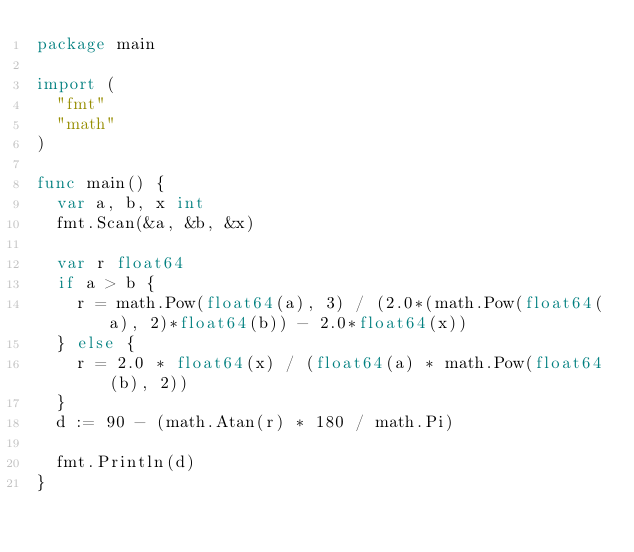<code> <loc_0><loc_0><loc_500><loc_500><_Go_>package main

import (
	"fmt"
	"math"
)

func main() {
	var a, b, x int
	fmt.Scan(&a, &b, &x)

	var r float64
	if a > b {
		r = math.Pow(float64(a), 3) / (2.0*(math.Pow(float64(a), 2)*float64(b)) - 2.0*float64(x))
	} else {
		r = 2.0 * float64(x) / (float64(a) * math.Pow(float64(b), 2))
	}
	d := 90 - (math.Atan(r) * 180 / math.Pi)

	fmt.Println(d)
}
</code> 